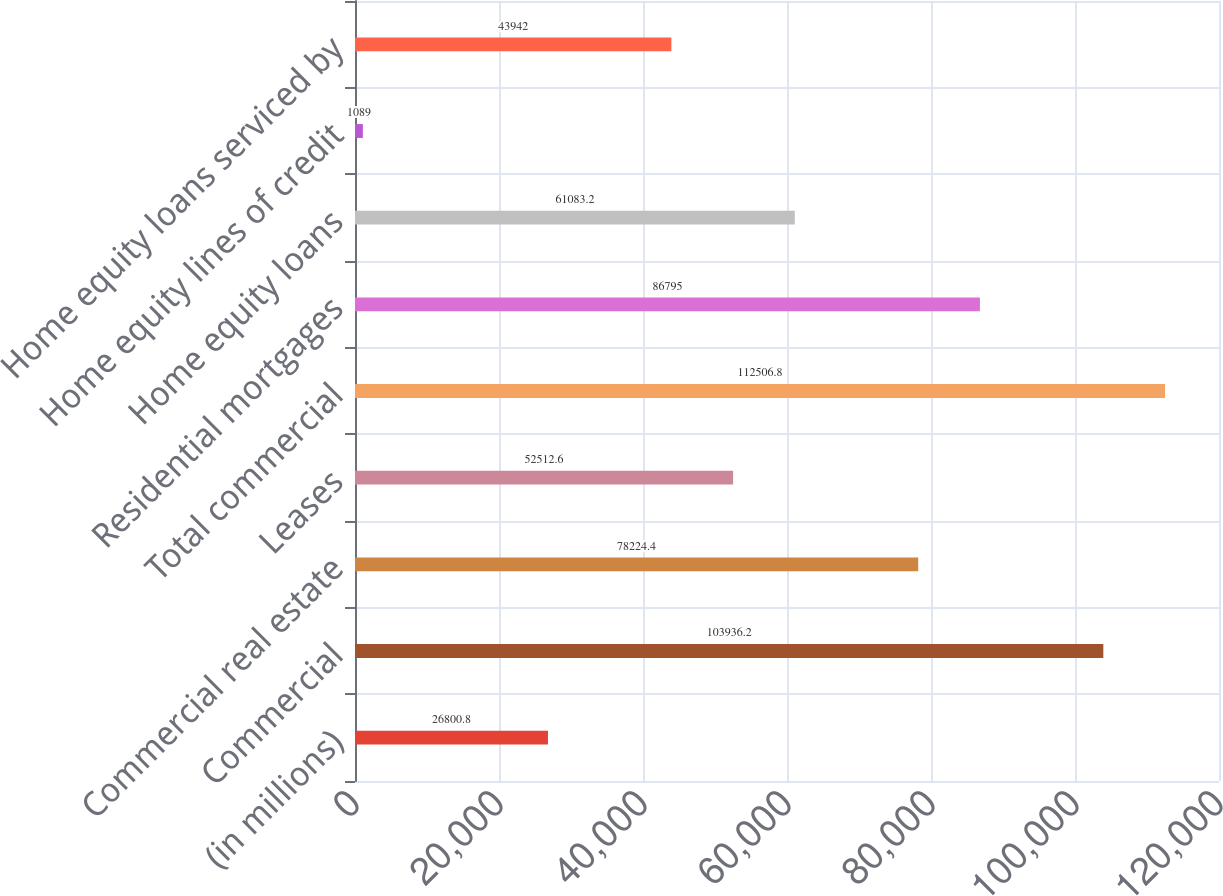Convert chart. <chart><loc_0><loc_0><loc_500><loc_500><bar_chart><fcel>(in millions)<fcel>Commercial<fcel>Commercial real estate<fcel>Leases<fcel>Total commercial<fcel>Residential mortgages<fcel>Home equity loans<fcel>Home equity lines of credit<fcel>Home equity loans serviced by<nl><fcel>26800.8<fcel>103936<fcel>78224.4<fcel>52512.6<fcel>112507<fcel>86795<fcel>61083.2<fcel>1089<fcel>43942<nl></chart> 